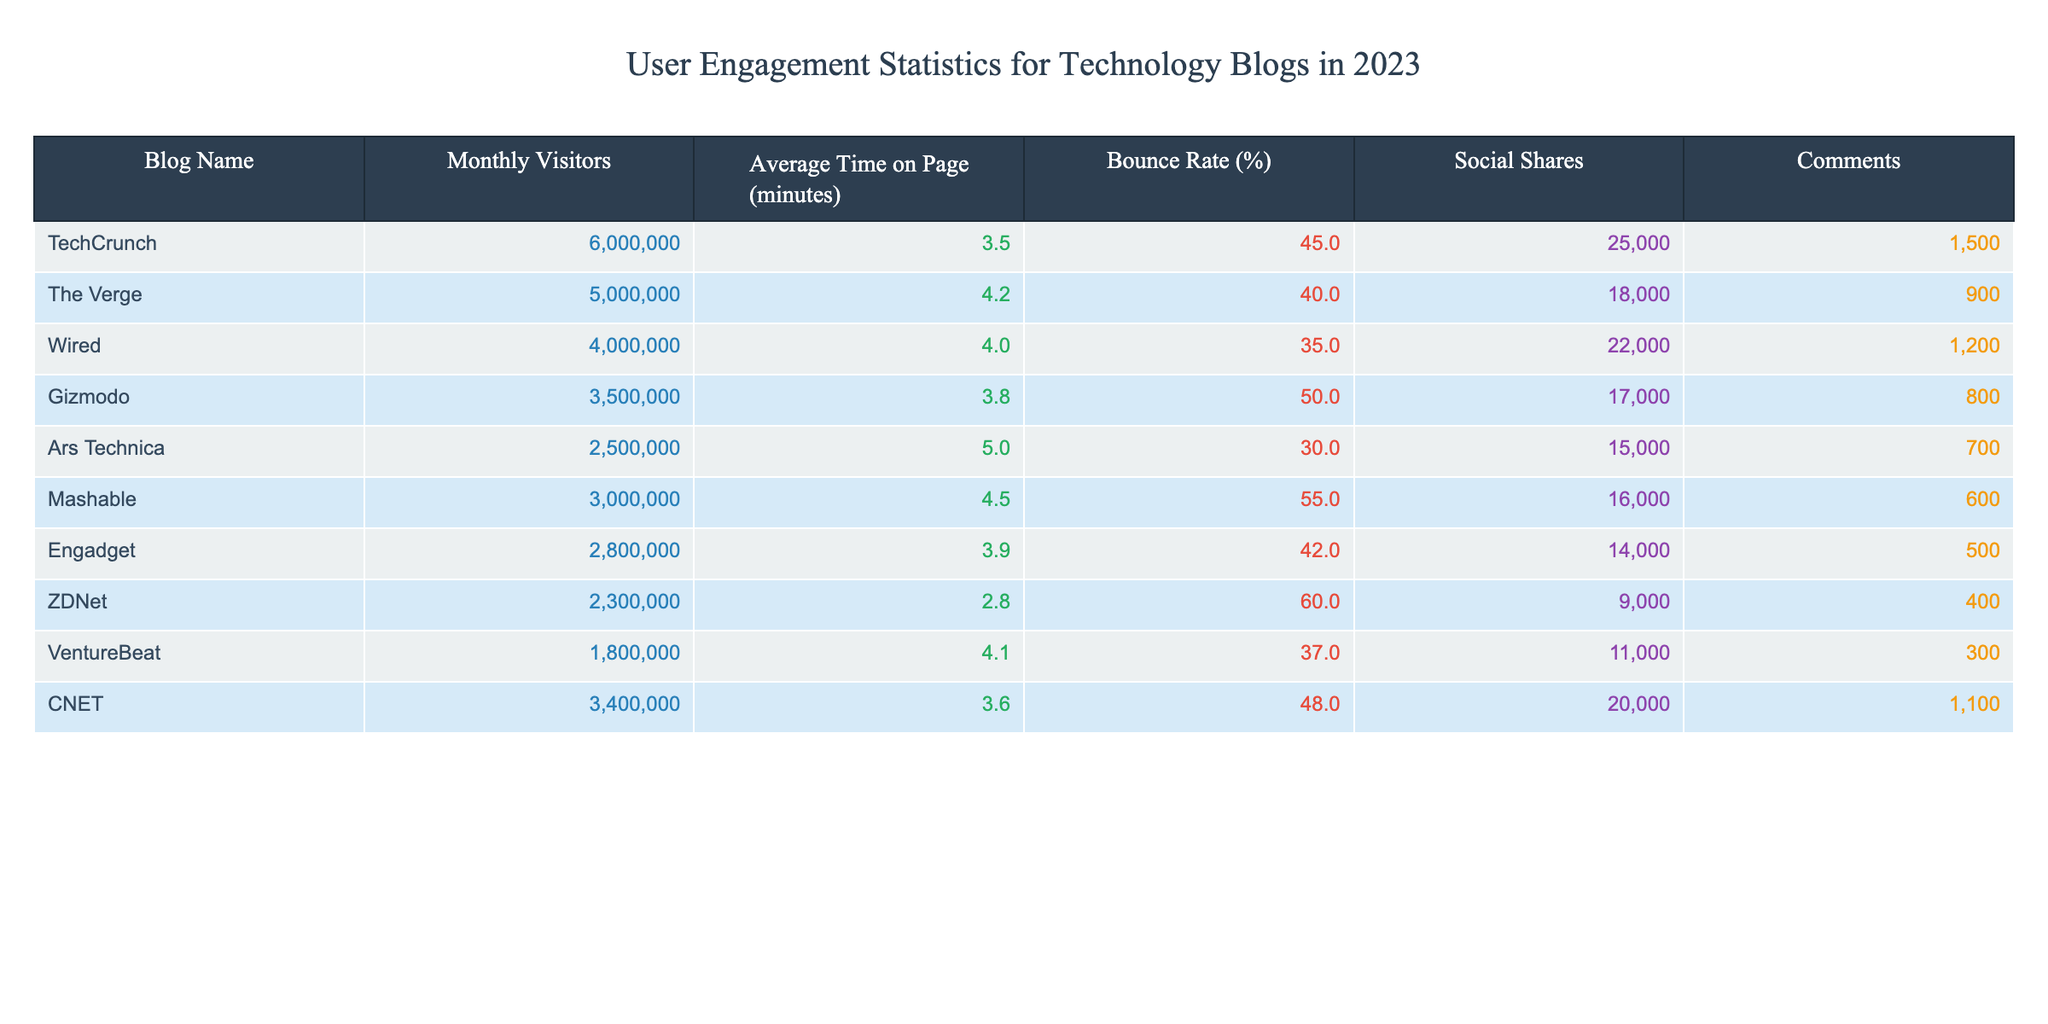What is the blog with the highest monthly visitors? According to the table, TechCrunch has the highest monthly visitors at 6,000,000.
Answer: TechCrunch What is the average time spent on the page for Wired? The average time spent on the page for Wired is listed in the table as 4.0 minutes.
Answer: 4.0 minutes Which blog has the lowest bounce rate? The blog with the lowest bounce rate is Ars Technica with a bounce rate of 30%.
Answer: Ars Technica What is the total number of social shares for TechCrunch and The Verge combined? TechCrunch has 25,000 social shares and The Verge has 18,000. Adding these together gives 25,000 + 18,000 = 43,000 social shares combined.
Answer: 43,000 Is the average time on page for Engadget more than 4 minutes? Engadget has an average time on page of 3.9 minutes, which is less than 4 minutes.
Answer: No What is the difference in monthly visitors between Gizmodo and ZDNet? Gizmodo has 3,500,000 monthly visitors while ZDNet has 2,300,000. The difference is 3,500,000 - 2,300,000 = 1,200,000 monthly visitors.
Answer: 1,200,000 What is the average bounce rate for all the blogs listed? The bounce rates are 45, 40, 35, 50, 30, 55, 42, 60, 37, and 48. Summing these gives 45 + 40 + 35 + 50 + 30 + 55 + 42 + 60 + 37 + 48 =  442. There are 10 blogs, so the average is 442 / 10 = 44.2%.
Answer: 44.2% Which blog received the most comments? TechCrunch received the most comments at 1,500 according to the table.
Answer: TechCrunch Is Wired more popular in terms of social shares than Mashable? Wired has 22,000 social shares while Mashable has 16,000, indicating Wired is indeed more popular in this regard.
Answer: Yes 